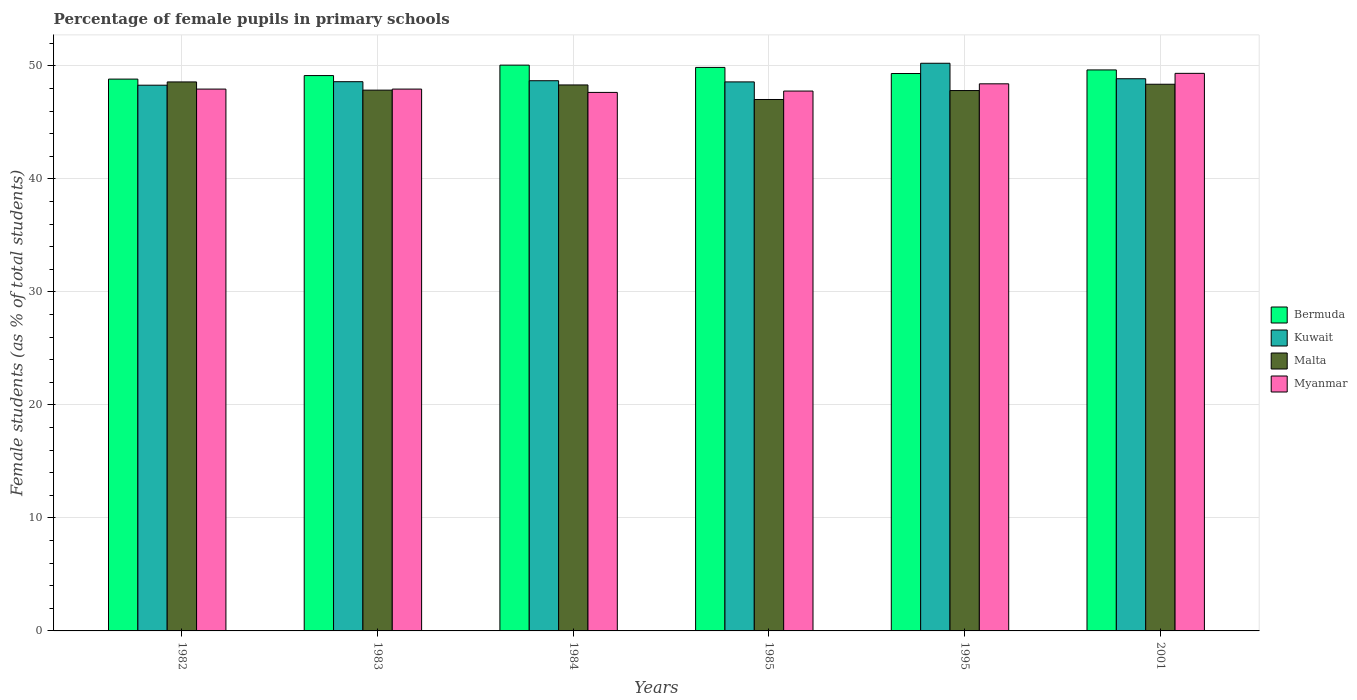How many bars are there on the 3rd tick from the left?
Your response must be concise. 4. How many bars are there on the 4th tick from the right?
Give a very brief answer. 4. What is the label of the 3rd group of bars from the left?
Ensure brevity in your answer.  1984. In how many cases, is the number of bars for a given year not equal to the number of legend labels?
Your answer should be very brief. 0. What is the percentage of female pupils in primary schools in Malta in 2001?
Give a very brief answer. 48.38. Across all years, what is the maximum percentage of female pupils in primary schools in Kuwait?
Your answer should be compact. 50.24. Across all years, what is the minimum percentage of female pupils in primary schools in Malta?
Give a very brief answer. 47.03. In which year was the percentage of female pupils in primary schools in Myanmar minimum?
Your answer should be compact. 1984. What is the total percentage of female pupils in primary schools in Kuwait in the graph?
Give a very brief answer. 293.29. What is the difference between the percentage of female pupils in primary schools in Kuwait in 1982 and that in 1985?
Provide a succinct answer. -0.29. What is the difference between the percentage of female pupils in primary schools in Myanmar in 1985 and the percentage of female pupils in primary schools in Kuwait in 1984?
Your answer should be very brief. -0.91. What is the average percentage of female pupils in primary schools in Malta per year?
Make the answer very short. 48. In the year 1983, what is the difference between the percentage of female pupils in primary schools in Myanmar and percentage of female pupils in primary schools in Kuwait?
Ensure brevity in your answer.  -0.66. In how many years, is the percentage of female pupils in primary schools in Bermuda greater than 44 %?
Ensure brevity in your answer.  6. What is the ratio of the percentage of female pupils in primary schools in Myanmar in 1984 to that in 1985?
Provide a short and direct response. 1. What is the difference between the highest and the second highest percentage of female pupils in primary schools in Kuwait?
Keep it short and to the point. 1.37. What is the difference between the highest and the lowest percentage of female pupils in primary schools in Bermuda?
Offer a very short reply. 1.24. In how many years, is the percentage of female pupils in primary schools in Kuwait greater than the average percentage of female pupils in primary schools in Kuwait taken over all years?
Your answer should be very brief. 1. Is it the case that in every year, the sum of the percentage of female pupils in primary schools in Malta and percentage of female pupils in primary schools in Kuwait is greater than the sum of percentage of female pupils in primary schools in Myanmar and percentage of female pupils in primary schools in Bermuda?
Provide a succinct answer. No. What does the 4th bar from the left in 1983 represents?
Your answer should be compact. Myanmar. What does the 3rd bar from the right in 1983 represents?
Your response must be concise. Kuwait. Are all the bars in the graph horizontal?
Your response must be concise. No. How many years are there in the graph?
Keep it short and to the point. 6. Are the values on the major ticks of Y-axis written in scientific E-notation?
Your answer should be compact. No. Does the graph contain grids?
Your answer should be very brief. Yes. How are the legend labels stacked?
Provide a short and direct response. Vertical. What is the title of the graph?
Offer a very short reply. Percentage of female pupils in primary schools. Does "Guam" appear as one of the legend labels in the graph?
Offer a very short reply. No. What is the label or title of the Y-axis?
Your answer should be very brief. Female students (as % of total students). What is the Female students (as % of total students) in Bermuda in 1982?
Your answer should be compact. 48.84. What is the Female students (as % of total students) in Kuwait in 1982?
Provide a succinct answer. 48.3. What is the Female students (as % of total students) in Malta in 1982?
Provide a succinct answer. 48.59. What is the Female students (as % of total students) in Myanmar in 1982?
Keep it short and to the point. 47.95. What is the Female students (as % of total students) of Bermuda in 1983?
Keep it short and to the point. 49.15. What is the Female students (as % of total students) in Kuwait in 1983?
Provide a succinct answer. 48.61. What is the Female students (as % of total students) in Malta in 1983?
Provide a short and direct response. 47.86. What is the Female students (as % of total students) of Myanmar in 1983?
Provide a succinct answer. 47.95. What is the Female students (as % of total students) in Bermuda in 1984?
Your response must be concise. 50.07. What is the Female students (as % of total students) in Kuwait in 1984?
Keep it short and to the point. 48.69. What is the Female students (as % of total students) of Malta in 1984?
Ensure brevity in your answer.  48.32. What is the Female students (as % of total students) of Myanmar in 1984?
Your answer should be compact. 47.66. What is the Female students (as % of total students) in Bermuda in 1985?
Make the answer very short. 49.87. What is the Female students (as % of total students) in Kuwait in 1985?
Offer a terse response. 48.59. What is the Female students (as % of total students) of Malta in 1985?
Provide a short and direct response. 47.03. What is the Female students (as % of total students) of Myanmar in 1985?
Give a very brief answer. 47.78. What is the Female students (as % of total students) in Bermuda in 1995?
Provide a succinct answer. 49.33. What is the Female students (as % of total students) of Kuwait in 1995?
Give a very brief answer. 50.24. What is the Female students (as % of total students) of Malta in 1995?
Offer a terse response. 47.82. What is the Female students (as % of total students) in Myanmar in 1995?
Make the answer very short. 48.42. What is the Female students (as % of total students) in Bermuda in 2001?
Ensure brevity in your answer.  49.65. What is the Female students (as % of total students) in Kuwait in 2001?
Ensure brevity in your answer.  48.87. What is the Female students (as % of total students) of Malta in 2001?
Keep it short and to the point. 48.38. What is the Female students (as % of total students) of Myanmar in 2001?
Your answer should be very brief. 49.35. Across all years, what is the maximum Female students (as % of total students) of Bermuda?
Provide a succinct answer. 50.07. Across all years, what is the maximum Female students (as % of total students) in Kuwait?
Provide a succinct answer. 50.24. Across all years, what is the maximum Female students (as % of total students) in Malta?
Keep it short and to the point. 48.59. Across all years, what is the maximum Female students (as % of total students) of Myanmar?
Give a very brief answer. 49.35. Across all years, what is the minimum Female students (as % of total students) of Bermuda?
Ensure brevity in your answer.  48.84. Across all years, what is the minimum Female students (as % of total students) in Kuwait?
Offer a terse response. 48.3. Across all years, what is the minimum Female students (as % of total students) of Malta?
Give a very brief answer. 47.03. Across all years, what is the minimum Female students (as % of total students) of Myanmar?
Give a very brief answer. 47.66. What is the total Female students (as % of total students) of Bermuda in the graph?
Your answer should be compact. 296.9. What is the total Female students (as % of total students) of Kuwait in the graph?
Provide a succinct answer. 293.29. What is the total Female students (as % of total students) in Malta in the graph?
Make the answer very short. 288. What is the total Female students (as % of total students) in Myanmar in the graph?
Keep it short and to the point. 289.1. What is the difference between the Female students (as % of total students) in Bermuda in 1982 and that in 1983?
Your answer should be very brief. -0.31. What is the difference between the Female students (as % of total students) in Kuwait in 1982 and that in 1983?
Ensure brevity in your answer.  -0.31. What is the difference between the Female students (as % of total students) in Malta in 1982 and that in 1983?
Keep it short and to the point. 0.73. What is the difference between the Female students (as % of total students) in Myanmar in 1982 and that in 1983?
Offer a terse response. -0. What is the difference between the Female students (as % of total students) of Bermuda in 1982 and that in 1984?
Your answer should be very brief. -1.24. What is the difference between the Female students (as % of total students) in Kuwait in 1982 and that in 1984?
Give a very brief answer. -0.4. What is the difference between the Female students (as % of total students) of Malta in 1982 and that in 1984?
Your response must be concise. 0.27. What is the difference between the Female students (as % of total students) in Myanmar in 1982 and that in 1984?
Provide a short and direct response. 0.29. What is the difference between the Female students (as % of total students) in Bermuda in 1982 and that in 1985?
Your response must be concise. -1.04. What is the difference between the Female students (as % of total students) of Kuwait in 1982 and that in 1985?
Provide a succinct answer. -0.29. What is the difference between the Female students (as % of total students) in Malta in 1982 and that in 1985?
Your response must be concise. 1.55. What is the difference between the Female students (as % of total students) in Myanmar in 1982 and that in 1985?
Your answer should be very brief. 0.17. What is the difference between the Female students (as % of total students) of Bermuda in 1982 and that in 1995?
Provide a succinct answer. -0.49. What is the difference between the Female students (as % of total students) in Kuwait in 1982 and that in 1995?
Provide a short and direct response. -1.94. What is the difference between the Female students (as % of total students) of Malta in 1982 and that in 1995?
Offer a very short reply. 0.76. What is the difference between the Female students (as % of total students) in Myanmar in 1982 and that in 1995?
Give a very brief answer. -0.47. What is the difference between the Female students (as % of total students) in Bermuda in 1982 and that in 2001?
Your answer should be compact. -0.81. What is the difference between the Female students (as % of total students) in Kuwait in 1982 and that in 2001?
Offer a very short reply. -0.57. What is the difference between the Female students (as % of total students) in Malta in 1982 and that in 2001?
Your response must be concise. 0.2. What is the difference between the Female students (as % of total students) of Myanmar in 1982 and that in 2001?
Give a very brief answer. -1.39. What is the difference between the Female students (as % of total students) of Bermuda in 1983 and that in 1984?
Make the answer very short. -0.92. What is the difference between the Female students (as % of total students) of Kuwait in 1983 and that in 1984?
Offer a very short reply. -0.08. What is the difference between the Female students (as % of total students) in Malta in 1983 and that in 1984?
Provide a succinct answer. -0.46. What is the difference between the Female students (as % of total students) of Myanmar in 1983 and that in 1984?
Offer a very short reply. 0.29. What is the difference between the Female students (as % of total students) of Bermuda in 1983 and that in 1985?
Give a very brief answer. -0.72. What is the difference between the Female students (as % of total students) of Kuwait in 1983 and that in 1985?
Give a very brief answer. 0.02. What is the difference between the Female students (as % of total students) in Malta in 1983 and that in 1985?
Give a very brief answer. 0.83. What is the difference between the Female students (as % of total students) in Myanmar in 1983 and that in 1985?
Your answer should be compact. 0.17. What is the difference between the Female students (as % of total students) in Bermuda in 1983 and that in 1995?
Provide a succinct answer. -0.18. What is the difference between the Female students (as % of total students) in Kuwait in 1983 and that in 1995?
Your answer should be very brief. -1.63. What is the difference between the Female students (as % of total students) in Malta in 1983 and that in 1995?
Your answer should be compact. 0.04. What is the difference between the Female students (as % of total students) of Myanmar in 1983 and that in 1995?
Your response must be concise. -0.47. What is the difference between the Female students (as % of total students) in Bermuda in 1983 and that in 2001?
Your answer should be very brief. -0.5. What is the difference between the Female students (as % of total students) in Kuwait in 1983 and that in 2001?
Your response must be concise. -0.26. What is the difference between the Female students (as % of total students) in Malta in 1983 and that in 2001?
Offer a terse response. -0.52. What is the difference between the Female students (as % of total students) in Myanmar in 1983 and that in 2001?
Provide a succinct answer. -1.39. What is the difference between the Female students (as % of total students) of Bermuda in 1984 and that in 1985?
Your answer should be compact. 0.2. What is the difference between the Female students (as % of total students) of Kuwait in 1984 and that in 1985?
Offer a terse response. 0.1. What is the difference between the Female students (as % of total students) in Malta in 1984 and that in 1985?
Your answer should be very brief. 1.29. What is the difference between the Female students (as % of total students) of Myanmar in 1984 and that in 1985?
Offer a very short reply. -0.12. What is the difference between the Female students (as % of total students) of Bermuda in 1984 and that in 1995?
Provide a short and direct response. 0.74. What is the difference between the Female students (as % of total students) of Kuwait in 1984 and that in 1995?
Make the answer very short. -1.55. What is the difference between the Female students (as % of total students) of Malta in 1984 and that in 1995?
Provide a succinct answer. 0.5. What is the difference between the Female students (as % of total students) in Myanmar in 1984 and that in 1995?
Your response must be concise. -0.76. What is the difference between the Female students (as % of total students) in Bermuda in 1984 and that in 2001?
Your response must be concise. 0.43. What is the difference between the Female students (as % of total students) in Kuwait in 1984 and that in 2001?
Your response must be concise. -0.18. What is the difference between the Female students (as % of total students) in Malta in 1984 and that in 2001?
Ensure brevity in your answer.  -0.06. What is the difference between the Female students (as % of total students) of Myanmar in 1984 and that in 2001?
Your answer should be very brief. -1.69. What is the difference between the Female students (as % of total students) in Bermuda in 1985 and that in 1995?
Provide a succinct answer. 0.54. What is the difference between the Female students (as % of total students) of Kuwait in 1985 and that in 1995?
Your response must be concise. -1.65. What is the difference between the Female students (as % of total students) in Malta in 1985 and that in 1995?
Provide a short and direct response. -0.79. What is the difference between the Female students (as % of total students) of Myanmar in 1985 and that in 1995?
Your answer should be very brief. -0.64. What is the difference between the Female students (as % of total students) in Bermuda in 1985 and that in 2001?
Your response must be concise. 0.22. What is the difference between the Female students (as % of total students) of Kuwait in 1985 and that in 2001?
Make the answer very short. -0.28. What is the difference between the Female students (as % of total students) in Malta in 1985 and that in 2001?
Your answer should be compact. -1.35. What is the difference between the Female students (as % of total students) in Myanmar in 1985 and that in 2001?
Keep it short and to the point. -1.57. What is the difference between the Female students (as % of total students) in Bermuda in 1995 and that in 2001?
Your response must be concise. -0.32. What is the difference between the Female students (as % of total students) in Kuwait in 1995 and that in 2001?
Give a very brief answer. 1.37. What is the difference between the Female students (as % of total students) in Malta in 1995 and that in 2001?
Your answer should be very brief. -0.56. What is the difference between the Female students (as % of total students) of Myanmar in 1995 and that in 2001?
Provide a short and direct response. -0.93. What is the difference between the Female students (as % of total students) of Bermuda in 1982 and the Female students (as % of total students) of Kuwait in 1983?
Your answer should be compact. 0.23. What is the difference between the Female students (as % of total students) of Bermuda in 1982 and the Female students (as % of total students) of Malta in 1983?
Provide a succinct answer. 0.98. What is the difference between the Female students (as % of total students) of Bermuda in 1982 and the Female students (as % of total students) of Myanmar in 1983?
Your answer should be very brief. 0.88. What is the difference between the Female students (as % of total students) in Kuwait in 1982 and the Female students (as % of total students) in Malta in 1983?
Your answer should be very brief. 0.44. What is the difference between the Female students (as % of total students) in Kuwait in 1982 and the Female students (as % of total students) in Myanmar in 1983?
Offer a very short reply. 0.34. What is the difference between the Female students (as % of total students) of Malta in 1982 and the Female students (as % of total students) of Myanmar in 1983?
Your answer should be compact. 0.63. What is the difference between the Female students (as % of total students) in Bermuda in 1982 and the Female students (as % of total students) in Kuwait in 1984?
Your response must be concise. 0.14. What is the difference between the Female students (as % of total students) in Bermuda in 1982 and the Female students (as % of total students) in Malta in 1984?
Provide a succinct answer. 0.52. What is the difference between the Female students (as % of total students) in Bermuda in 1982 and the Female students (as % of total students) in Myanmar in 1984?
Ensure brevity in your answer.  1.18. What is the difference between the Female students (as % of total students) in Kuwait in 1982 and the Female students (as % of total students) in Malta in 1984?
Provide a succinct answer. -0.02. What is the difference between the Female students (as % of total students) of Kuwait in 1982 and the Female students (as % of total students) of Myanmar in 1984?
Keep it short and to the point. 0.64. What is the difference between the Female students (as % of total students) in Malta in 1982 and the Female students (as % of total students) in Myanmar in 1984?
Ensure brevity in your answer.  0.93. What is the difference between the Female students (as % of total students) of Bermuda in 1982 and the Female students (as % of total students) of Kuwait in 1985?
Make the answer very short. 0.25. What is the difference between the Female students (as % of total students) of Bermuda in 1982 and the Female students (as % of total students) of Malta in 1985?
Make the answer very short. 1.8. What is the difference between the Female students (as % of total students) of Bermuda in 1982 and the Female students (as % of total students) of Myanmar in 1985?
Provide a succinct answer. 1.06. What is the difference between the Female students (as % of total students) in Kuwait in 1982 and the Female students (as % of total students) in Malta in 1985?
Ensure brevity in your answer.  1.27. What is the difference between the Female students (as % of total students) in Kuwait in 1982 and the Female students (as % of total students) in Myanmar in 1985?
Make the answer very short. 0.52. What is the difference between the Female students (as % of total students) of Malta in 1982 and the Female students (as % of total students) of Myanmar in 1985?
Your answer should be very brief. 0.81. What is the difference between the Female students (as % of total students) in Bermuda in 1982 and the Female students (as % of total students) in Kuwait in 1995?
Your answer should be compact. -1.4. What is the difference between the Female students (as % of total students) in Bermuda in 1982 and the Female students (as % of total students) in Malta in 1995?
Provide a short and direct response. 1.01. What is the difference between the Female students (as % of total students) in Bermuda in 1982 and the Female students (as % of total students) in Myanmar in 1995?
Make the answer very short. 0.42. What is the difference between the Female students (as % of total students) of Kuwait in 1982 and the Female students (as % of total students) of Malta in 1995?
Offer a terse response. 0.47. What is the difference between the Female students (as % of total students) in Kuwait in 1982 and the Female students (as % of total students) in Myanmar in 1995?
Make the answer very short. -0.12. What is the difference between the Female students (as % of total students) of Malta in 1982 and the Female students (as % of total students) of Myanmar in 1995?
Provide a succinct answer. 0.17. What is the difference between the Female students (as % of total students) of Bermuda in 1982 and the Female students (as % of total students) of Kuwait in 2001?
Provide a short and direct response. -0.03. What is the difference between the Female students (as % of total students) in Bermuda in 1982 and the Female students (as % of total students) in Malta in 2001?
Give a very brief answer. 0.45. What is the difference between the Female students (as % of total students) in Bermuda in 1982 and the Female students (as % of total students) in Myanmar in 2001?
Your answer should be very brief. -0.51. What is the difference between the Female students (as % of total students) in Kuwait in 1982 and the Female students (as % of total students) in Malta in 2001?
Keep it short and to the point. -0.08. What is the difference between the Female students (as % of total students) of Kuwait in 1982 and the Female students (as % of total students) of Myanmar in 2001?
Offer a terse response. -1.05. What is the difference between the Female students (as % of total students) in Malta in 1982 and the Female students (as % of total students) in Myanmar in 2001?
Your response must be concise. -0.76. What is the difference between the Female students (as % of total students) of Bermuda in 1983 and the Female students (as % of total students) of Kuwait in 1984?
Provide a short and direct response. 0.46. What is the difference between the Female students (as % of total students) of Bermuda in 1983 and the Female students (as % of total students) of Malta in 1984?
Ensure brevity in your answer.  0.83. What is the difference between the Female students (as % of total students) in Bermuda in 1983 and the Female students (as % of total students) in Myanmar in 1984?
Ensure brevity in your answer.  1.49. What is the difference between the Female students (as % of total students) of Kuwait in 1983 and the Female students (as % of total students) of Malta in 1984?
Your response must be concise. 0.29. What is the difference between the Female students (as % of total students) of Kuwait in 1983 and the Female students (as % of total students) of Myanmar in 1984?
Provide a short and direct response. 0.95. What is the difference between the Female students (as % of total students) of Malta in 1983 and the Female students (as % of total students) of Myanmar in 1984?
Keep it short and to the point. 0.2. What is the difference between the Female students (as % of total students) of Bermuda in 1983 and the Female students (as % of total students) of Kuwait in 1985?
Provide a succinct answer. 0.56. What is the difference between the Female students (as % of total students) in Bermuda in 1983 and the Female students (as % of total students) in Malta in 1985?
Provide a short and direct response. 2.12. What is the difference between the Female students (as % of total students) of Bermuda in 1983 and the Female students (as % of total students) of Myanmar in 1985?
Provide a short and direct response. 1.37. What is the difference between the Female students (as % of total students) in Kuwait in 1983 and the Female students (as % of total students) in Malta in 1985?
Make the answer very short. 1.58. What is the difference between the Female students (as % of total students) of Kuwait in 1983 and the Female students (as % of total students) of Myanmar in 1985?
Keep it short and to the point. 0.83. What is the difference between the Female students (as % of total students) of Malta in 1983 and the Female students (as % of total students) of Myanmar in 1985?
Make the answer very short. 0.08. What is the difference between the Female students (as % of total students) in Bermuda in 1983 and the Female students (as % of total students) in Kuwait in 1995?
Your response must be concise. -1.09. What is the difference between the Female students (as % of total students) of Bermuda in 1983 and the Female students (as % of total students) of Malta in 1995?
Make the answer very short. 1.33. What is the difference between the Female students (as % of total students) in Bermuda in 1983 and the Female students (as % of total students) in Myanmar in 1995?
Offer a very short reply. 0.73. What is the difference between the Female students (as % of total students) of Kuwait in 1983 and the Female students (as % of total students) of Malta in 1995?
Provide a short and direct response. 0.78. What is the difference between the Female students (as % of total students) in Kuwait in 1983 and the Female students (as % of total students) in Myanmar in 1995?
Offer a terse response. 0.19. What is the difference between the Female students (as % of total students) of Malta in 1983 and the Female students (as % of total students) of Myanmar in 1995?
Provide a short and direct response. -0.56. What is the difference between the Female students (as % of total students) in Bermuda in 1983 and the Female students (as % of total students) in Kuwait in 2001?
Your response must be concise. 0.28. What is the difference between the Female students (as % of total students) of Bermuda in 1983 and the Female students (as % of total students) of Malta in 2001?
Ensure brevity in your answer.  0.77. What is the difference between the Female students (as % of total students) of Bermuda in 1983 and the Female students (as % of total students) of Myanmar in 2001?
Your answer should be very brief. -0.2. What is the difference between the Female students (as % of total students) in Kuwait in 1983 and the Female students (as % of total students) in Malta in 2001?
Provide a succinct answer. 0.23. What is the difference between the Female students (as % of total students) of Kuwait in 1983 and the Female students (as % of total students) of Myanmar in 2001?
Keep it short and to the point. -0.74. What is the difference between the Female students (as % of total students) of Malta in 1983 and the Female students (as % of total students) of Myanmar in 2001?
Offer a terse response. -1.49. What is the difference between the Female students (as % of total students) in Bermuda in 1984 and the Female students (as % of total students) in Kuwait in 1985?
Your response must be concise. 1.48. What is the difference between the Female students (as % of total students) in Bermuda in 1984 and the Female students (as % of total students) in Malta in 1985?
Your answer should be compact. 3.04. What is the difference between the Female students (as % of total students) of Bermuda in 1984 and the Female students (as % of total students) of Myanmar in 1985?
Make the answer very short. 2.29. What is the difference between the Female students (as % of total students) in Kuwait in 1984 and the Female students (as % of total students) in Malta in 1985?
Keep it short and to the point. 1.66. What is the difference between the Female students (as % of total students) in Kuwait in 1984 and the Female students (as % of total students) in Myanmar in 1985?
Your answer should be very brief. 0.91. What is the difference between the Female students (as % of total students) in Malta in 1984 and the Female students (as % of total students) in Myanmar in 1985?
Offer a very short reply. 0.54. What is the difference between the Female students (as % of total students) of Bermuda in 1984 and the Female students (as % of total students) of Kuwait in 1995?
Provide a succinct answer. -0.17. What is the difference between the Female students (as % of total students) of Bermuda in 1984 and the Female students (as % of total students) of Malta in 1995?
Ensure brevity in your answer.  2.25. What is the difference between the Female students (as % of total students) of Bermuda in 1984 and the Female students (as % of total students) of Myanmar in 1995?
Keep it short and to the point. 1.65. What is the difference between the Female students (as % of total students) of Kuwait in 1984 and the Female students (as % of total students) of Malta in 1995?
Your response must be concise. 0.87. What is the difference between the Female students (as % of total students) of Kuwait in 1984 and the Female students (as % of total students) of Myanmar in 1995?
Offer a very short reply. 0.27. What is the difference between the Female students (as % of total students) in Malta in 1984 and the Female students (as % of total students) in Myanmar in 1995?
Offer a terse response. -0.1. What is the difference between the Female students (as % of total students) in Bermuda in 1984 and the Female students (as % of total students) in Kuwait in 2001?
Your answer should be compact. 1.2. What is the difference between the Female students (as % of total students) in Bermuda in 1984 and the Female students (as % of total students) in Malta in 2001?
Keep it short and to the point. 1.69. What is the difference between the Female students (as % of total students) in Bermuda in 1984 and the Female students (as % of total students) in Myanmar in 2001?
Ensure brevity in your answer.  0.73. What is the difference between the Female students (as % of total students) of Kuwait in 1984 and the Female students (as % of total students) of Malta in 2001?
Offer a very short reply. 0.31. What is the difference between the Female students (as % of total students) of Kuwait in 1984 and the Female students (as % of total students) of Myanmar in 2001?
Provide a short and direct response. -0.65. What is the difference between the Female students (as % of total students) in Malta in 1984 and the Female students (as % of total students) in Myanmar in 2001?
Provide a short and direct response. -1.03. What is the difference between the Female students (as % of total students) of Bermuda in 1985 and the Female students (as % of total students) of Kuwait in 1995?
Your answer should be compact. -0.37. What is the difference between the Female students (as % of total students) in Bermuda in 1985 and the Female students (as % of total students) in Malta in 1995?
Your response must be concise. 2.05. What is the difference between the Female students (as % of total students) of Bermuda in 1985 and the Female students (as % of total students) of Myanmar in 1995?
Provide a short and direct response. 1.45. What is the difference between the Female students (as % of total students) of Kuwait in 1985 and the Female students (as % of total students) of Malta in 1995?
Your response must be concise. 0.77. What is the difference between the Female students (as % of total students) of Kuwait in 1985 and the Female students (as % of total students) of Myanmar in 1995?
Offer a very short reply. 0.17. What is the difference between the Female students (as % of total students) of Malta in 1985 and the Female students (as % of total students) of Myanmar in 1995?
Keep it short and to the point. -1.39. What is the difference between the Female students (as % of total students) of Bermuda in 1985 and the Female students (as % of total students) of Kuwait in 2001?
Offer a very short reply. 1. What is the difference between the Female students (as % of total students) of Bermuda in 1985 and the Female students (as % of total students) of Malta in 2001?
Offer a very short reply. 1.49. What is the difference between the Female students (as % of total students) of Bermuda in 1985 and the Female students (as % of total students) of Myanmar in 2001?
Offer a terse response. 0.53. What is the difference between the Female students (as % of total students) in Kuwait in 1985 and the Female students (as % of total students) in Malta in 2001?
Offer a very short reply. 0.21. What is the difference between the Female students (as % of total students) of Kuwait in 1985 and the Female students (as % of total students) of Myanmar in 2001?
Offer a very short reply. -0.76. What is the difference between the Female students (as % of total students) of Malta in 1985 and the Female students (as % of total students) of Myanmar in 2001?
Make the answer very short. -2.31. What is the difference between the Female students (as % of total students) of Bermuda in 1995 and the Female students (as % of total students) of Kuwait in 2001?
Give a very brief answer. 0.46. What is the difference between the Female students (as % of total students) in Bermuda in 1995 and the Female students (as % of total students) in Malta in 2001?
Offer a terse response. 0.95. What is the difference between the Female students (as % of total students) in Bermuda in 1995 and the Female students (as % of total students) in Myanmar in 2001?
Ensure brevity in your answer.  -0.02. What is the difference between the Female students (as % of total students) of Kuwait in 1995 and the Female students (as % of total students) of Malta in 2001?
Keep it short and to the point. 1.86. What is the difference between the Female students (as % of total students) in Kuwait in 1995 and the Female students (as % of total students) in Myanmar in 2001?
Provide a succinct answer. 0.89. What is the difference between the Female students (as % of total students) in Malta in 1995 and the Female students (as % of total students) in Myanmar in 2001?
Your answer should be very brief. -1.52. What is the average Female students (as % of total students) in Bermuda per year?
Provide a succinct answer. 49.48. What is the average Female students (as % of total students) in Kuwait per year?
Provide a succinct answer. 48.88. What is the average Female students (as % of total students) of Malta per year?
Ensure brevity in your answer.  48. What is the average Female students (as % of total students) of Myanmar per year?
Ensure brevity in your answer.  48.18. In the year 1982, what is the difference between the Female students (as % of total students) in Bermuda and Female students (as % of total students) in Kuwait?
Give a very brief answer. 0.54. In the year 1982, what is the difference between the Female students (as % of total students) in Bermuda and Female students (as % of total students) in Malta?
Your response must be concise. 0.25. In the year 1982, what is the difference between the Female students (as % of total students) in Bermuda and Female students (as % of total students) in Myanmar?
Provide a succinct answer. 0.88. In the year 1982, what is the difference between the Female students (as % of total students) of Kuwait and Female students (as % of total students) of Malta?
Make the answer very short. -0.29. In the year 1982, what is the difference between the Female students (as % of total students) in Kuwait and Female students (as % of total students) in Myanmar?
Provide a succinct answer. 0.34. In the year 1982, what is the difference between the Female students (as % of total students) in Malta and Female students (as % of total students) in Myanmar?
Provide a short and direct response. 0.63. In the year 1983, what is the difference between the Female students (as % of total students) of Bermuda and Female students (as % of total students) of Kuwait?
Keep it short and to the point. 0.54. In the year 1983, what is the difference between the Female students (as % of total students) of Bermuda and Female students (as % of total students) of Malta?
Provide a short and direct response. 1.29. In the year 1983, what is the difference between the Female students (as % of total students) of Bermuda and Female students (as % of total students) of Myanmar?
Provide a succinct answer. 1.2. In the year 1983, what is the difference between the Female students (as % of total students) in Kuwait and Female students (as % of total students) in Malta?
Your answer should be very brief. 0.75. In the year 1983, what is the difference between the Female students (as % of total students) of Kuwait and Female students (as % of total students) of Myanmar?
Offer a very short reply. 0.66. In the year 1983, what is the difference between the Female students (as % of total students) in Malta and Female students (as % of total students) in Myanmar?
Your response must be concise. -0.09. In the year 1984, what is the difference between the Female students (as % of total students) in Bermuda and Female students (as % of total students) in Kuwait?
Ensure brevity in your answer.  1.38. In the year 1984, what is the difference between the Female students (as % of total students) of Bermuda and Female students (as % of total students) of Malta?
Offer a very short reply. 1.75. In the year 1984, what is the difference between the Female students (as % of total students) of Bermuda and Female students (as % of total students) of Myanmar?
Your answer should be compact. 2.42. In the year 1984, what is the difference between the Female students (as % of total students) of Kuwait and Female students (as % of total students) of Malta?
Make the answer very short. 0.37. In the year 1984, what is the difference between the Female students (as % of total students) of Kuwait and Female students (as % of total students) of Myanmar?
Provide a succinct answer. 1.03. In the year 1984, what is the difference between the Female students (as % of total students) of Malta and Female students (as % of total students) of Myanmar?
Your response must be concise. 0.66. In the year 1985, what is the difference between the Female students (as % of total students) in Bermuda and Female students (as % of total students) in Kuwait?
Keep it short and to the point. 1.28. In the year 1985, what is the difference between the Female students (as % of total students) of Bermuda and Female students (as % of total students) of Malta?
Provide a succinct answer. 2.84. In the year 1985, what is the difference between the Female students (as % of total students) of Bermuda and Female students (as % of total students) of Myanmar?
Offer a very short reply. 2.09. In the year 1985, what is the difference between the Female students (as % of total students) in Kuwait and Female students (as % of total students) in Malta?
Your answer should be compact. 1.56. In the year 1985, what is the difference between the Female students (as % of total students) of Kuwait and Female students (as % of total students) of Myanmar?
Provide a short and direct response. 0.81. In the year 1985, what is the difference between the Female students (as % of total students) of Malta and Female students (as % of total students) of Myanmar?
Your response must be concise. -0.75. In the year 1995, what is the difference between the Female students (as % of total students) of Bermuda and Female students (as % of total students) of Kuwait?
Keep it short and to the point. -0.91. In the year 1995, what is the difference between the Female students (as % of total students) of Bermuda and Female students (as % of total students) of Malta?
Offer a very short reply. 1.51. In the year 1995, what is the difference between the Female students (as % of total students) in Bermuda and Female students (as % of total students) in Myanmar?
Provide a short and direct response. 0.91. In the year 1995, what is the difference between the Female students (as % of total students) in Kuwait and Female students (as % of total students) in Malta?
Your answer should be compact. 2.42. In the year 1995, what is the difference between the Female students (as % of total students) of Kuwait and Female students (as % of total students) of Myanmar?
Your answer should be compact. 1.82. In the year 1995, what is the difference between the Female students (as % of total students) of Malta and Female students (as % of total students) of Myanmar?
Your answer should be very brief. -0.6. In the year 2001, what is the difference between the Female students (as % of total students) of Bermuda and Female students (as % of total students) of Kuwait?
Ensure brevity in your answer.  0.78. In the year 2001, what is the difference between the Female students (as % of total students) of Bermuda and Female students (as % of total students) of Malta?
Keep it short and to the point. 1.27. In the year 2001, what is the difference between the Female students (as % of total students) in Bermuda and Female students (as % of total students) in Myanmar?
Your answer should be very brief. 0.3. In the year 2001, what is the difference between the Female students (as % of total students) in Kuwait and Female students (as % of total students) in Malta?
Your answer should be compact. 0.49. In the year 2001, what is the difference between the Female students (as % of total students) of Kuwait and Female students (as % of total students) of Myanmar?
Provide a short and direct response. -0.48. In the year 2001, what is the difference between the Female students (as % of total students) in Malta and Female students (as % of total students) in Myanmar?
Your answer should be compact. -0.96. What is the ratio of the Female students (as % of total students) in Kuwait in 1982 to that in 1983?
Your answer should be very brief. 0.99. What is the ratio of the Female students (as % of total students) of Malta in 1982 to that in 1983?
Your answer should be very brief. 1.02. What is the ratio of the Female students (as % of total students) of Myanmar in 1982 to that in 1983?
Offer a terse response. 1. What is the ratio of the Female students (as % of total students) of Bermuda in 1982 to that in 1984?
Make the answer very short. 0.98. What is the ratio of the Female students (as % of total students) of Kuwait in 1982 to that in 1984?
Your answer should be compact. 0.99. What is the ratio of the Female students (as % of total students) in Myanmar in 1982 to that in 1984?
Provide a succinct answer. 1.01. What is the ratio of the Female students (as % of total students) of Bermuda in 1982 to that in 1985?
Keep it short and to the point. 0.98. What is the ratio of the Female students (as % of total students) in Kuwait in 1982 to that in 1985?
Your answer should be very brief. 0.99. What is the ratio of the Female students (as % of total students) in Malta in 1982 to that in 1985?
Your answer should be very brief. 1.03. What is the ratio of the Female students (as % of total students) in Kuwait in 1982 to that in 1995?
Your response must be concise. 0.96. What is the ratio of the Female students (as % of total students) in Malta in 1982 to that in 1995?
Your answer should be compact. 1.02. What is the ratio of the Female students (as % of total students) in Myanmar in 1982 to that in 1995?
Keep it short and to the point. 0.99. What is the ratio of the Female students (as % of total students) of Bermuda in 1982 to that in 2001?
Offer a terse response. 0.98. What is the ratio of the Female students (as % of total students) in Kuwait in 1982 to that in 2001?
Give a very brief answer. 0.99. What is the ratio of the Female students (as % of total students) of Myanmar in 1982 to that in 2001?
Offer a terse response. 0.97. What is the ratio of the Female students (as % of total students) in Bermuda in 1983 to that in 1984?
Provide a succinct answer. 0.98. What is the ratio of the Female students (as % of total students) in Kuwait in 1983 to that in 1984?
Your answer should be compact. 1. What is the ratio of the Female students (as % of total students) of Malta in 1983 to that in 1984?
Ensure brevity in your answer.  0.99. What is the ratio of the Female students (as % of total students) of Bermuda in 1983 to that in 1985?
Your answer should be compact. 0.99. What is the ratio of the Female students (as % of total students) in Kuwait in 1983 to that in 1985?
Make the answer very short. 1. What is the ratio of the Female students (as % of total students) in Malta in 1983 to that in 1985?
Provide a short and direct response. 1.02. What is the ratio of the Female students (as % of total students) of Kuwait in 1983 to that in 1995?
Your answer should be very brief. 0.97. What is the ratio of the Female students (as % of total students) of Kuwait in 1983 to that in 2001?
Ensure brevity in your answer.  0.99. What is the ratio of the Female students (as % of total students) in Malta in 1983 to that in 2001?
Provide a short and direct response. 0.99. What is the ratio of the Female students (as % of total students) in Myanmar in 1983 to that in 2001?
Give a very brief answer. 0.97. What is the ratio of the Female students (as % of total students) of Malta in 1984 to that in 1985?
Provide a short and direct response. 1.03. What is the ratio of the Female students (as % of total students) of Bermuda in 1984 to that in 1995?
Keep it short and to the point. 1.02. What is the ratio of the Female students (as % of total students) in Kuwait in 1984 to that in 1995?
Offer a terse response. 0.97. What is the ratio of the Female students (as % of total students) of Malta in 1984 to that in 1995?
Keep it short and to the point. 1.01. What is the ratio of the Female students (as % of total students) in Myanmar in 1984 to that in 1995?
Give a very brief answer. 0.98. What is the ratio of the Female students (as % of total students) of Bermuda in 1984 to that in 2001?
Provide a short and direct response. 1.01. What is the ratio of the Female students (as % of total students) in Kuwait in 1984 to that in 2001?
Your response must be concise. 1. What is the ratio of the Female students (as % of total students) of Malta in 1984 to that in 2001?
Make the answer very short. 1. What is the ratio of the Female students (as % of total students) of Myanmar in 1984 to that in 2001?
Keep it short and to the point. 0.97. What is the ratio of the Female students (as % of total students) of Bermuda in 1985 to that in 1995?
Ensure brevity in your answer.  1.01. What is the ratio of the Female students (as % of total students) in Kuwait in 1985 to that in 1995?
Provide a short and direct response. 0.97. What is the ratio of the Female students (as % of total students) of Malta in 1985 to that in 1995?
Ensure brevity in your answer.  0.98. What is the ratio of the Female students (as % of total students) of Myanmar in 1985 to that in 1995?
Your answer should be very brief. 0.99. What is the ratio of the Female students (as % of total students) of Kuwait in 1985 to that in 2001?
Make the answer very short. 0.99. What is the ratio of the Female students (as % of total students) of Malta in 1985 to that in 2001?
Offer a terse response. 0.97. What is the ratio of the Female students (as % of total students) of Myanmar in 1985 to that in 2001?
Your answer should be very brief. 0.97. What is the ratio of the Female students (as % of total students) of Bermuda in 1995 to that in 2001?
Your answer should be compact. 0.99. What is the ratio of the Female students (as % of total students) in Kuwait in 1995 to that in 2001?
Ensure brevity in your answer.  1.03. What is the ratio of the Female students (as % of total students) in Malta in 1995 to that in 2001?
Your answer should be compact. 0.99. What is the ratio of the Female students (as % of total students) in Myanmar in 1995 to that in 2001?
Your answer should be compact. 0.98. What is the difference between the highest and the second highest Female students (as % of total students) in Bermuda?
Ensure brevity in your answer.  0.2. What is the difference between the highest and the second highest Female students (as % of total students) of Kuwait?
Ensure brevity in your answer.  1.37. What is the difference between the highest and the second highest Female students (as % of total students) in Malta?
Your answer should be compact. 0.2. What is the difference between the highest and the second highest Female students (as % of total students) of Myanmar?
Offer a very short reply. 0.93. What is the difference between the highest and the lowest Female students (as % of total students) in Bermuda?
Give a very brief answer. 1.24. What is the difference between the highest and the lowest Female students (as % of total students) of Kuwait?
Provide a succinct answer. 1.94. What is the difference between the highest and the lowest Female students (as % of total students) of Malta?
Keep it short and to the point. 1.55. What is the difference between the highest and the lowest Female students (as % of total students) in Myanmar?
Offer a very short reply. 1.69. 